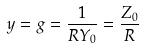<formula> <loc_0><loc_0><loc_500><loc_500>y = g = \frac { 1 } { R Y _ { 0 } } = \frac { Z _ { 0 } } { R }</formula> 